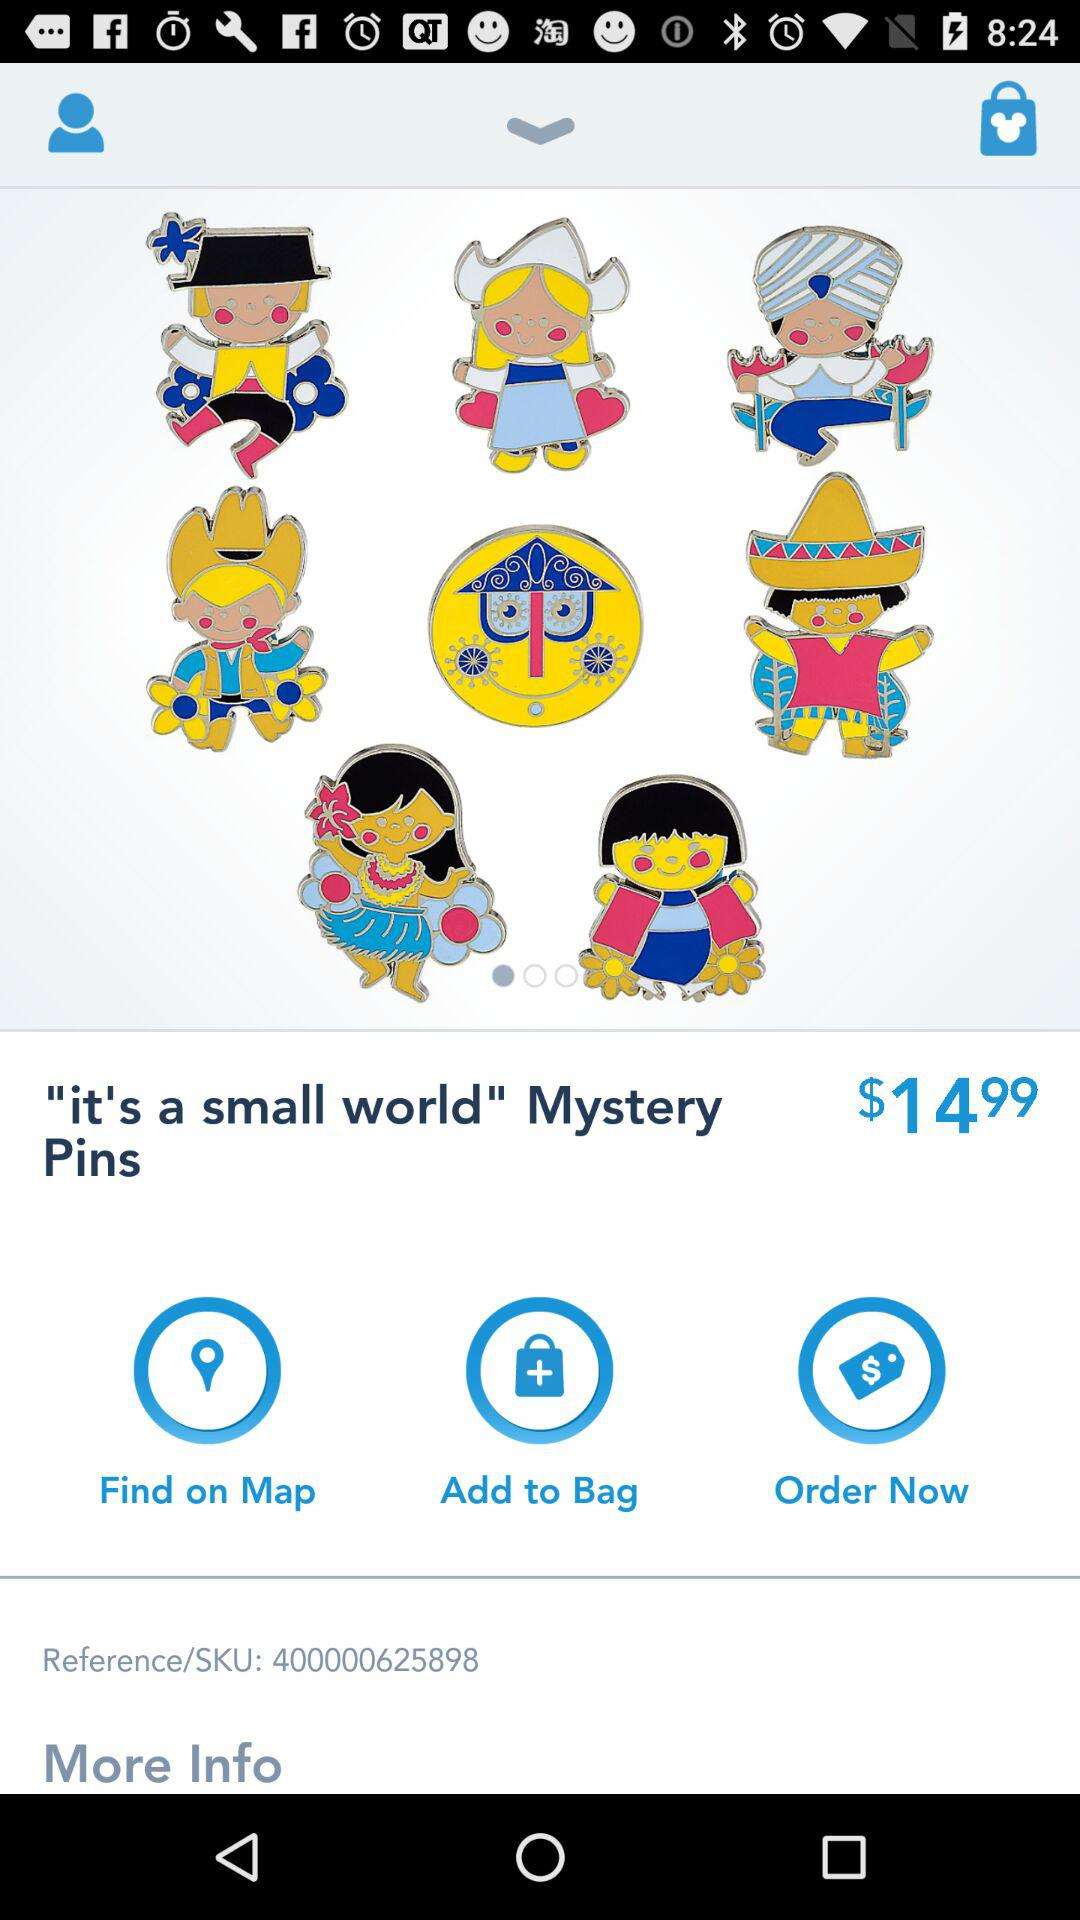What is the price of "Pins"? The price is $14.99. 